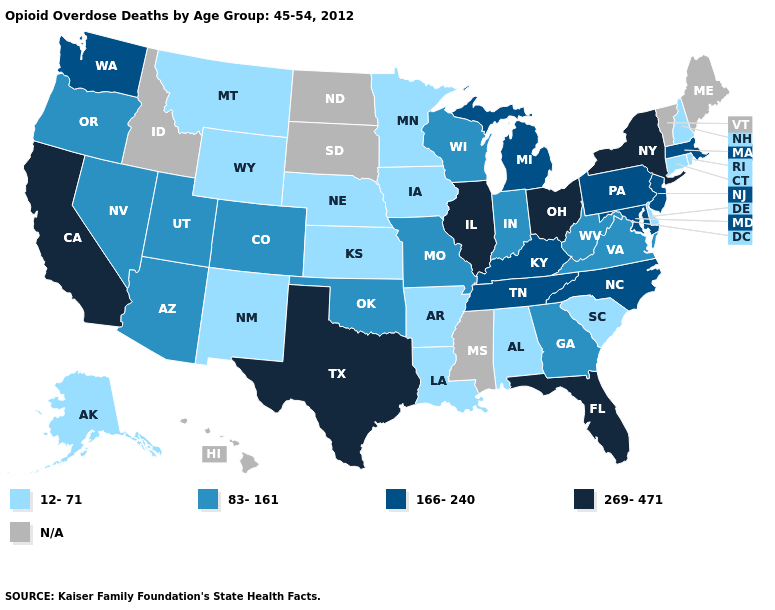Name the states that have a value in the range 269-471?
Write a very short answer. California, Florida, Illinois, New York, Ohio, Texas. Among the states that border Kentucky , does Ohio have the highest value?
Write a very short answer. Yes. Name the states that have a value in the range 12-71?
Keep it brief. Alabama, Alaska, Arkansas, Connecticut, Delaware, Iowa, Kansas, Louisiana, Minnesota, Montana, Nebraska, New Hampshire, New Mexico, Rhode Island, South Carolina, Wyoming. Among the states that border West Virginia , does Virginia have the lowest value?
Quick response, please. Yes. Which states have the lowest value in the USA?
Give a very brief answer. Alabama, Alaska, Arkansas, Connecticut, Delaware, Iowa, Kansas, Louisiana, Minnesota, Montana, Nebraska, New Hampshire, New Mexico, Rhode Island, South Carolina, Wyoming. Which states have the lowest value in the South?
Short answer required. Alabama, Arkansas, Delaware, Louisiana, South Carolina. Among the states that border Vermont , does Massachusetts have the lowest value?
Quick response, please. No. What is the highest value in states that border Michigan?
Write a very short answer. 269-471. Among the states that border Mississippi , does Arkansas have the highest value?
Quick response, please. No. What is the value of Oklahoma?
Quick response, please. 83-161. Name the states that have a value in the range N/A?
Short answer required. Hawaii, Idaho, Maine, Mississippi, North Dakota, South Dakota, Vermont. Name the states that have a value in the range 83-161?
Give a very brief answer. Arizona, Colorado, Georgia, Indiana, Missouri, Nevada, Oklahoma, Oregon, Utah, Virginia, West Virginia, Wisconsin. What is the highest value in states that border Tennessee?
Be succinct. 166-240. 